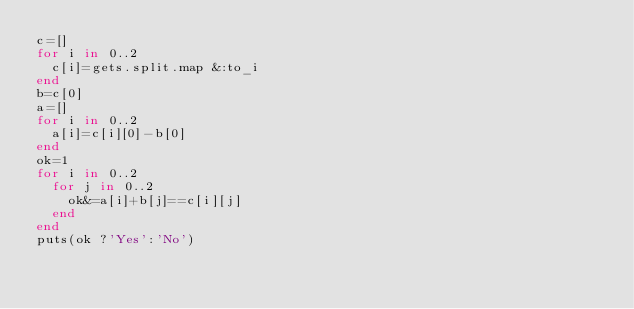<code> <loc_0><loc_0><loc_500><loc_500><_Ruby_>c=[]
for i in 0..2
  c[i]=gets.split.map &:to_i
end
b=c[0]
a=[]
for i in 0..2
  a[i]=c[i][0]-b[0]
end
ok=1
for i in 0..2
  for j in 0..2
    ok&=a[i]+b[j]==c[i][j]
  end
end
puts(ok ?'Yes':'No')



</code> 